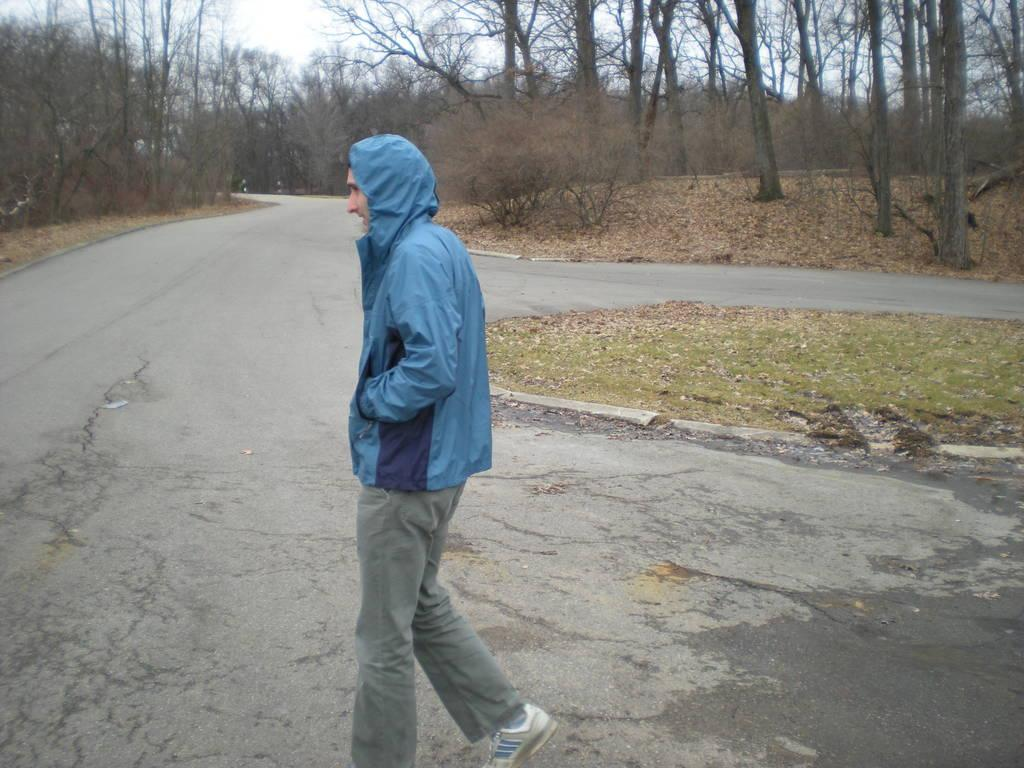Who is present in the image? There is a person in the image. What is the person wearing? The person is wearing a blue jacket. Where is the person standing? The person is standing on the road. What can be seen on either side of the person? There are dried trees on either side of the person. How does the person increase the volume of the hand in the image? There is no mention of a hand or volume in the image; the person is simply standing on the road with dried trees on either side. 